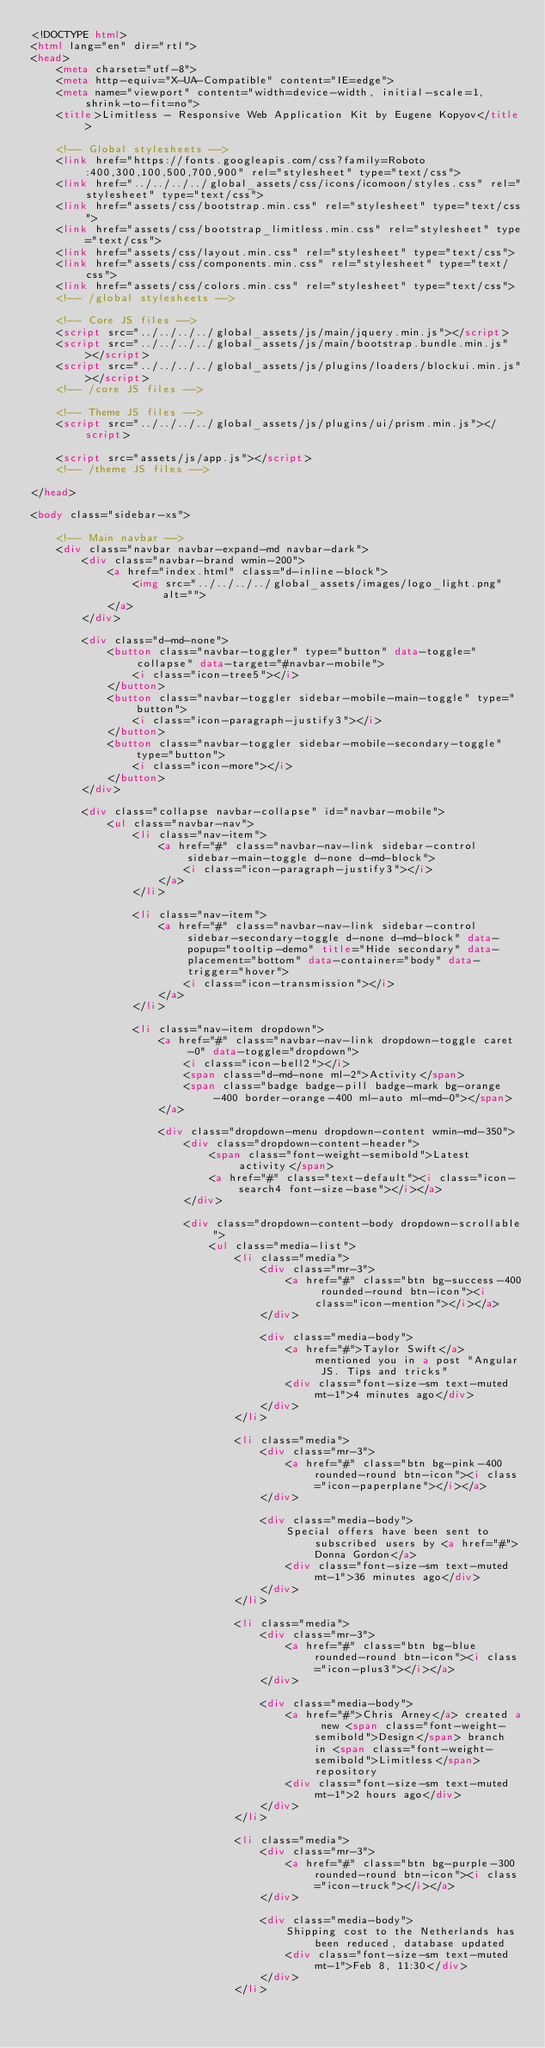Convert code to text. <code><loc_0><loc_0><loc_500><loc_500><_HTML_><!DOCTYPE html>
<html lang="en" dir="rtl">
<head>
	<meta charset="utf-8">
	<meta http-equiv="X-UA-Compatible" content="IE=edge">
	<meta name="viewport" content="width=device-width, initial-scale=1, shrink-to-fit=no">
	<title>Limitless - Responsive Web Application Kit by Eugene Kopyov</title>

	<!-- Global stylesheets -->
	<link href="https://fonts.googleapis.com/css?family=Roboto:400,300,100,500,700,900" rel="stylesheet" type="text/css">
	<link href="../../../../global_assets/css/icons/icomoon/styles.css" rel="stylesheet" type="text/css">
	<link href="assets/css/bootstrap.min.css" rel="stylesheet" type="text/css">
	<link href="assets/css/bootstrap_limitless.min.css" rel="stylesheet" type="text/css">
	<link href="assets/css/layout.min.css" rel="stylesheet" type="text/css">
	<link href="assets/css/components.min.css" rel="stylesheet" type="text/css">
	<link href="assets/css/colors.min.css" rel="stylesheet" type="text/css">
	<!-- /global stylesheets -->

	<!-- Core JS files -->
	<script src="../../../../global_assets/js/main/jquery.min.js"></script>
	<script src="../../../../global_assets/js/main/bootstrap.bundle.min.js"></script>
	<script src="../../../../global_assets/js/plugins/loaders/blockui.min.js"></script>
	<!-- /core JS files -->

	<!-- Theme JS files -->
	<script src="../../../../global_assets/js/plugins/ui/prism.min.js"></script>

	<script src="assets/js/app.js"></script>
	<!-- /theme JS files -->

</head>

<body class="sidebar-xs">

	<!-- Main navbar -->
	<div class="navbar navbar-expand-md navbar-dark">
		<div class="navbar-brand wmin-200">
			<a href="index.html" class="d-inline-block">
				<img src="../../../../global_assets/images/logo_light.png" alt="">
			</a>
		</div>

		<div class="d-md-none">
			<button class="navbar-toggler" type="button" data-toggle="collapse" data-target="#navbar-mobile">
				<i class="icon-tree5"></i>
			</button>
			<button class="navbar-toggler sidebar-mobile-main-toggle" type="button">
				<i class="icon-paragraph-justify3"></i>
			</button>
			<button class="navbar-toggler sidebar-mobile-secondary-toggle" type="button">
				<i class="icon-more"></i>
			</button>
		</div>

		<div class="collapse navbar-collapse" id="navbar-mobile">
			<ul class="navbar-nav">
				<li class="nav-item">
					<a href="#" class="navbar-nav-link sidebar-control sidebar-main-toggle d-none d-md-block">
						<i class="icon-paragraph-justify3"></i>
					</a>
				</li>

				<li class="nav-item">
					<a href="#" class="navbar-nav-link sidebar-control sidebar-secondary-toggle d-none d-md-block" data-popup="tooltip-demo" title="Hide secondary" data-placement="bottom" data-container="body" data-trigger="hover">
						<i class="icon-transmission"></i>
					</a>
				</li>

				<li class="nav-item dropdown">
					<a href="#" class="navbar-nav-link dropdown-toggle caret-0" data-toggle="dropdown">
						<i class="icon-bell2"></i>
						<span class="d-md-none ml-2">Activity</span>
						<span class="badge badge-pill badge-mark bg-orange-400 border-orange-400 ml-auto ml-md-0"></span>
					</a>
					
					<div class="dropdown-menu dropdown-content wmin-md-350">
						<div class="dropdown-content-header">
							<span class="font-weight-semibold">Latest activity</span>
							<a href="#" class="text-default"><i class="icon-search4 font-size-base"></i></a>
						</div>

						<div class="dropdown-content-body dropdown-scrollable">
							<ul class="media-list">
								<li class="media">
									<div class="mr-3">
										<a href="#" class="btn bg-success-400 rounded-round btn-icon"><i class="icon-mention"></i></a>
									</div>

									<div class="media-body">
										<a href="#">Taylor Swift</a> mentioned you in a post "Angular JS. Tips and tricks"
										<div class="font-size-sm text-muted mt-1">4 minutes ago</div>
									</div>
								</li>

								<li class="media">
									<div class="mr-3">
										<a href="#" class="btn bg-pink-400 rounded-round btn-icon"><i class="icon-paperplane"></i></a>
									</div>
									
									<div class="media-body">
										Special offers have been sent to subscribed users by <a href="#">Donna Gordon</a>
										<div class="font-size-sm text-muted mt-1">36 minutes ago</div>
									</div>
								</li>

								<li class="media">
									<div class="mr-3">
										<a href="#" class="btn bg-blue rounded-round btn-icon"><i class="icon-plus3"></i></a>
									</div>
									
									<div class="media-body">
										<a href="#">Chris Arney</a> created a new <span class="font-weight-semibold">Design</span> branch in <span class="font-weight-semibold">Limitless</span> repository
										<div class="font-size-sm text-muted mt-1">2 hours ago</div>
									</div>
								</li>

								<li class="media">
									<div class="mr-3">
										<a href="#" class="btn bg-purple-300 rounded-round btn-icon"><i class="icon-truck"></i></a>
									</div>
									
									<div class="media-body">
										Shipping cost to the Netherlands has been reduced, database updated
										<div class="font-size-sm text-muted mt-1">Feb 8, 11:30</div>
									</div>
								</li>
</code> 